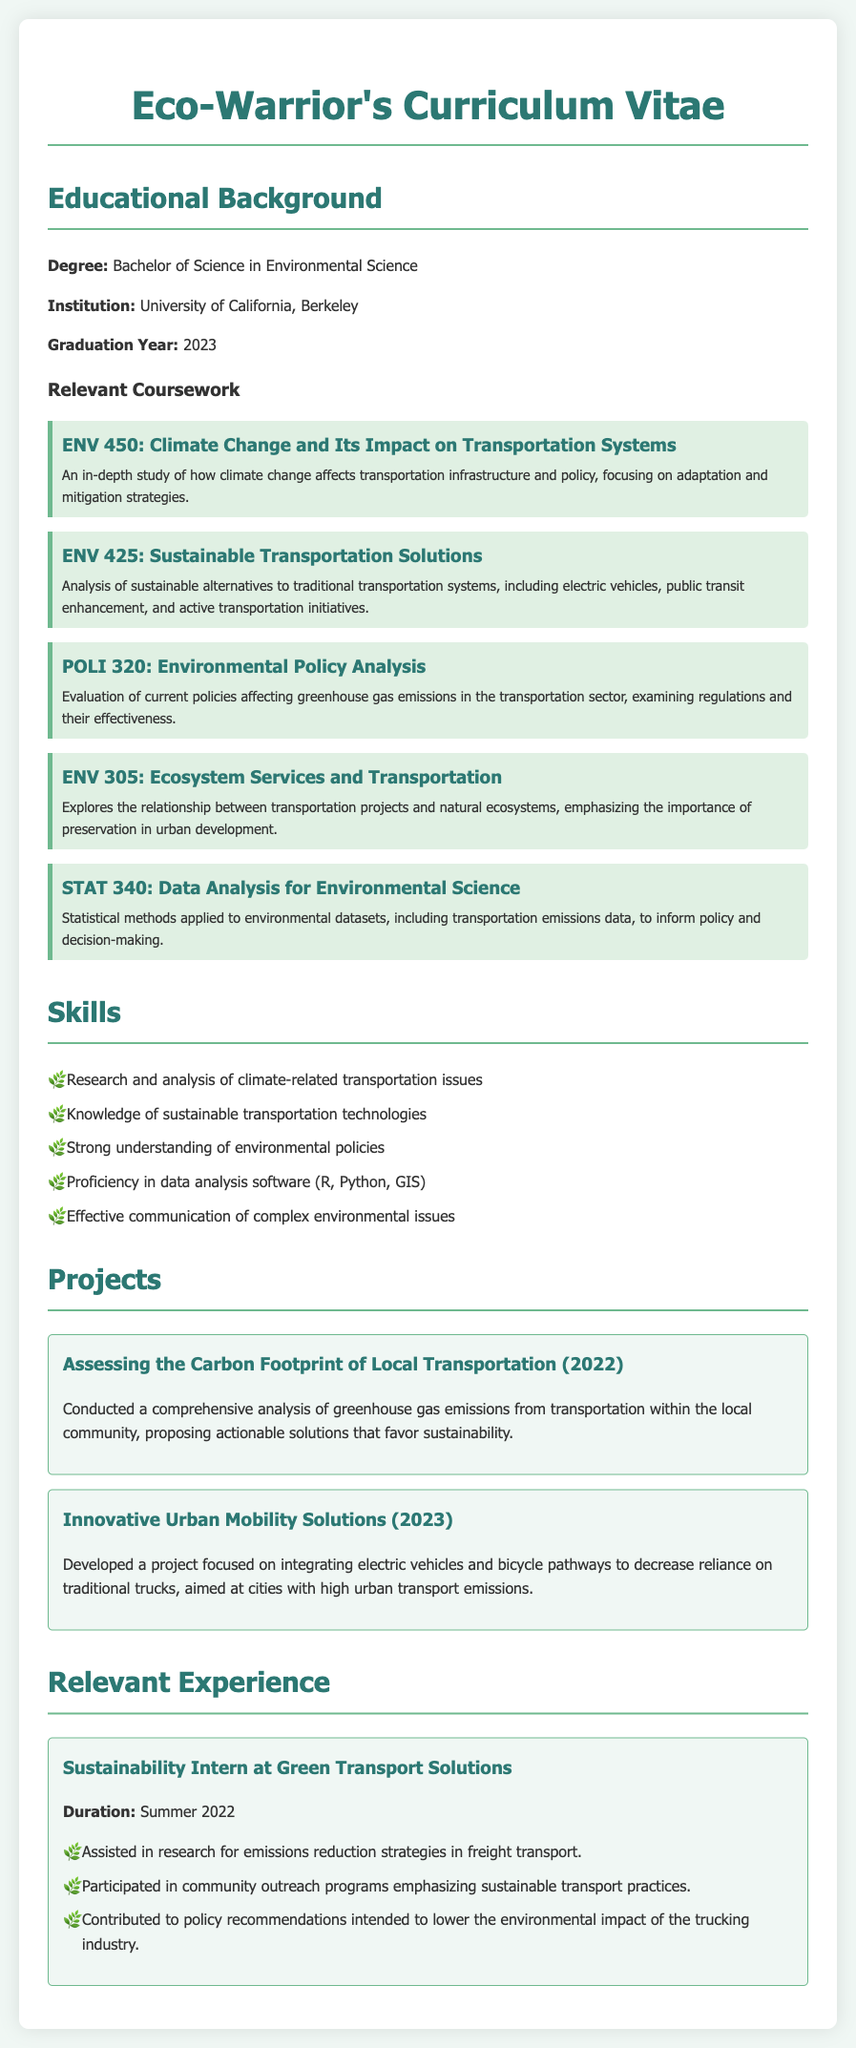What degree is listed in the CV? The degree listed is Bachelor of Science in Environmental Science.
Answer: Bachelor of Science in Environmental Science What institution did the individual graduate from? The individual graduated from the University of California, Berkeley.
Answer: University of California, Berkeley What year did they graduate? The graduation year mentioned in the CV is 2023.
Answer: 2023 Which course focuses on climate change and transportation systems? The course that focuses on climate change and transportation systems is ENV 450: Climate Change and Its Impact on Transportation Systems.
Answer: ENV 450: Climate Change and Its Impact on Transportation Systems What kind of projects did the individual work on? The individual worked on projects assessing carbon footprints and innovative urban mobility solutions.
Answer: Assessing the Carbon Footprint of Local Transportation, Innovative Urban Mobility Solutions What was the main focus of the course ENV 425? ENV 425 focuses on the analysis of sustainable alternatives to traditional transportation systems.
Answer: Sustainable alternatives to traditional transportation systems How long was the individual's internship at Green Transport Solutions? The document states the duration of the internship was Summer 2022.
Answer: Summer 2022 What important policy issues did the individual evaluate in the course POLI 320? In POLI 320, the individual evaluated current policies affecting greenhouse gas emissions in the transportation sector.
Answer: Current policies affecting greenhouse gas emissions in the transportation sector What skills related to data analysis does the individual possess? The individual possesses proficiency in data analysis software (R, Python, GIS).
Answer: R, Python, GIS What was one of the goals of the project Innovative Urban Mobility Solutions? One of the goals was to decrease reliance on traditional trucks.
Answer: Decrease reliance on traditional trucks 